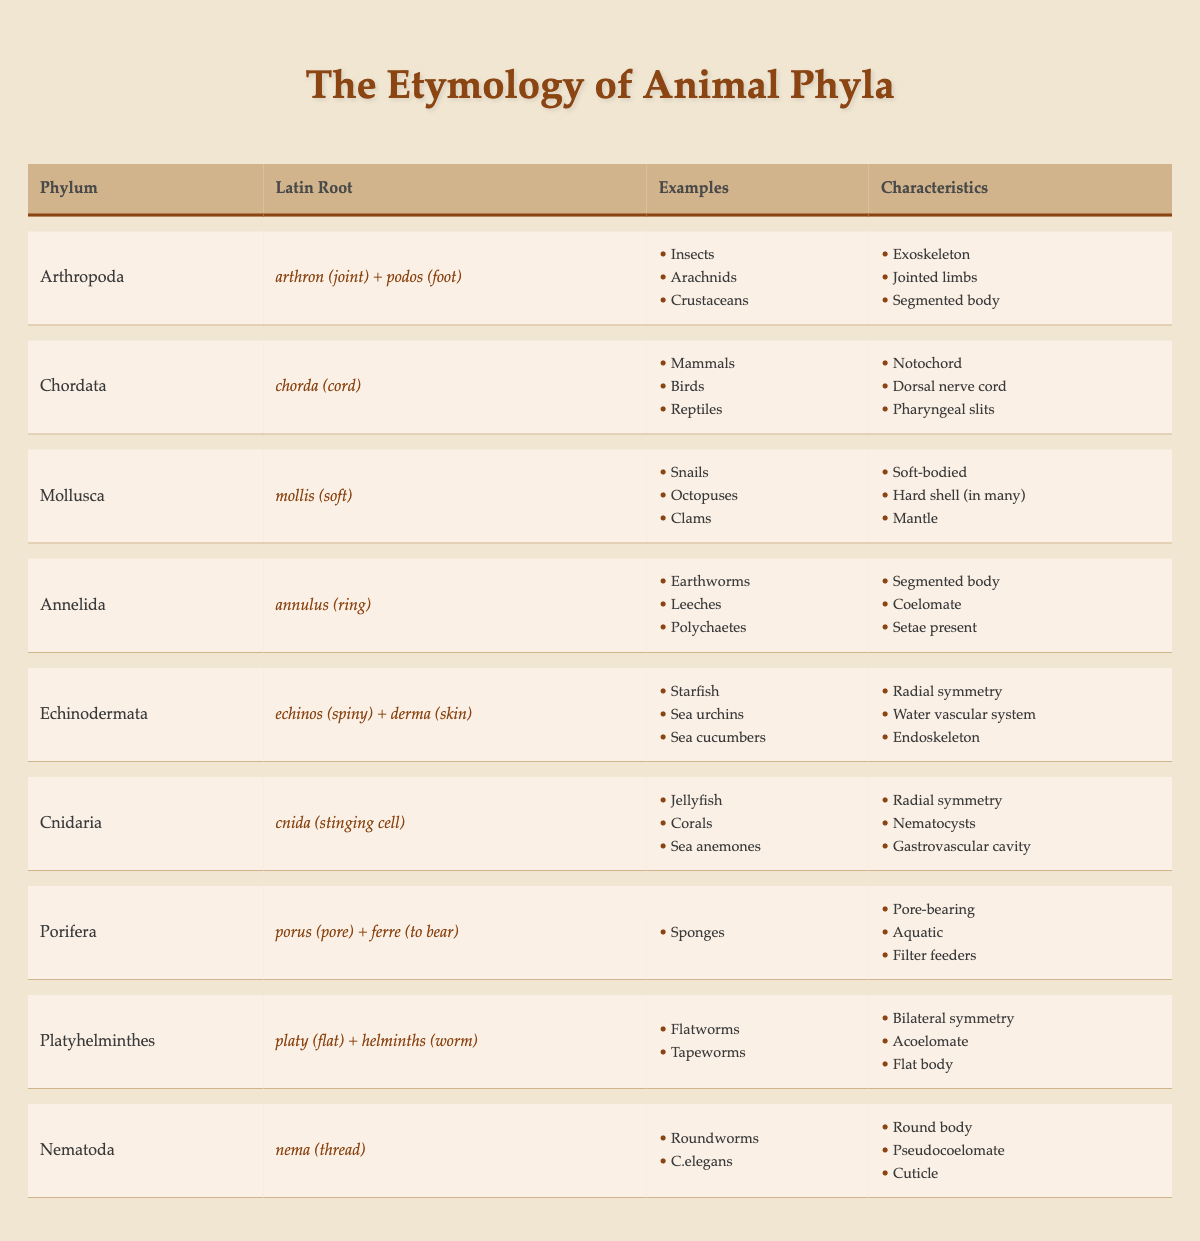What is the Latin root for the phylum Mollusca? The table states that the Latin root for Mollusca is "mollis (soft)."
Answer: mollis (soft) Which phylum includes organisms with jointed limbs? According to the table, the phylum Arthropoda has the characteristic of jointed limbs.
Answer: Arthropoda Do all animal phyla listed have segmented bodies? Not all phyla have segmented bodies; for example, Porifera does not show this characteristic.
Answer: No What is the relation between the phylum Chordata and the dorsal nerve cord? The table indicates that Chordata is associated with having a dorsal nerve cord as a characteristic.
Answer: Dorsal nerve cord Which phylum has the Latin root meaning "pore-bearing"? Porifera is mentioned in the table as having the Latin root "porus (pore) + ferre (to bear)."
Answer: Porifera How many examples of organisms are provided for the phylum Echinodermata? The examples for Echinodermata listed in the table are Starfish, Sea urchins, and Sea cucumbers, which totals three.
Answer: Three What unique system do Echinodermata possess that is mentioned in the table? The table indicates that Echinodermata have a water vascular system as one of their characteristics.
Answer: Water vascular system Is the phylum Annelida associated with an acoelomate body structure? The table notes that Annelida has a "coelomate" listed among its characteristics, indicating it is not acoelomate.
Answer: No Which phylum is described with a Latin root that translates to "flat worm"? The Latin root "platy (flat) + helminths (worm)" corresponds to the phylum Platyhelminthes.
Answer: Platyhelminthes Do any examples within the phylum Cnidaria include corals? Yes, the table lists corals as one of the examples under the phylum Cnidaria.
Answer: Yes What are the characteristics of Nematoda as stated in the table? Nematoda is described as having a round body, being pseudocoelomate, and having a cuticle as characteristics in the table.
Answer: Round body, pseudocoelomate, cuticle How does the number of foot-related organisms in Arthropoda compare to that in Mollusca? Arthropoda includes three examples of organisms (Insects, Arachnids, Crustaceans), while Mollusca has three examples (Snails, Octopuses, Clams), so they are equal in number.
Answer: They are equal What distinguishes Cnidaria from Arthropoda based on their characteristics? Cnidaria has radial symmetry and nematocysts listed as characteristics, while Arthropoda has jointed limbs and an exoskeleton, showing a fundamental biomechanical difference.
Answer: Different characteristics Are organisms in the phylum Porifera considered filter feeders? Yes, the table confirms that filter feeding is one of the characteristics associated with the phylum Porifera.
Answer: Yes Which phylum features a notochord according to the table? The table specifies that the phylum Chordata features a notochord as one of its defining characteristics.
Answer: Chordata 